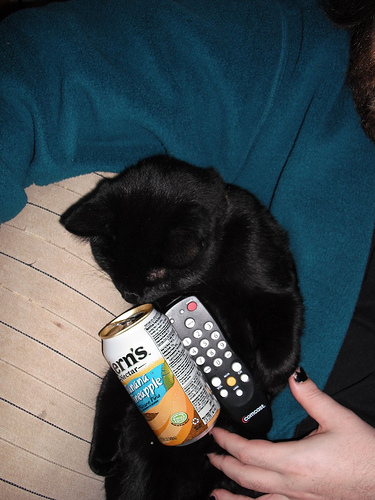Read all the text in this image. ern's ctar ineapple 